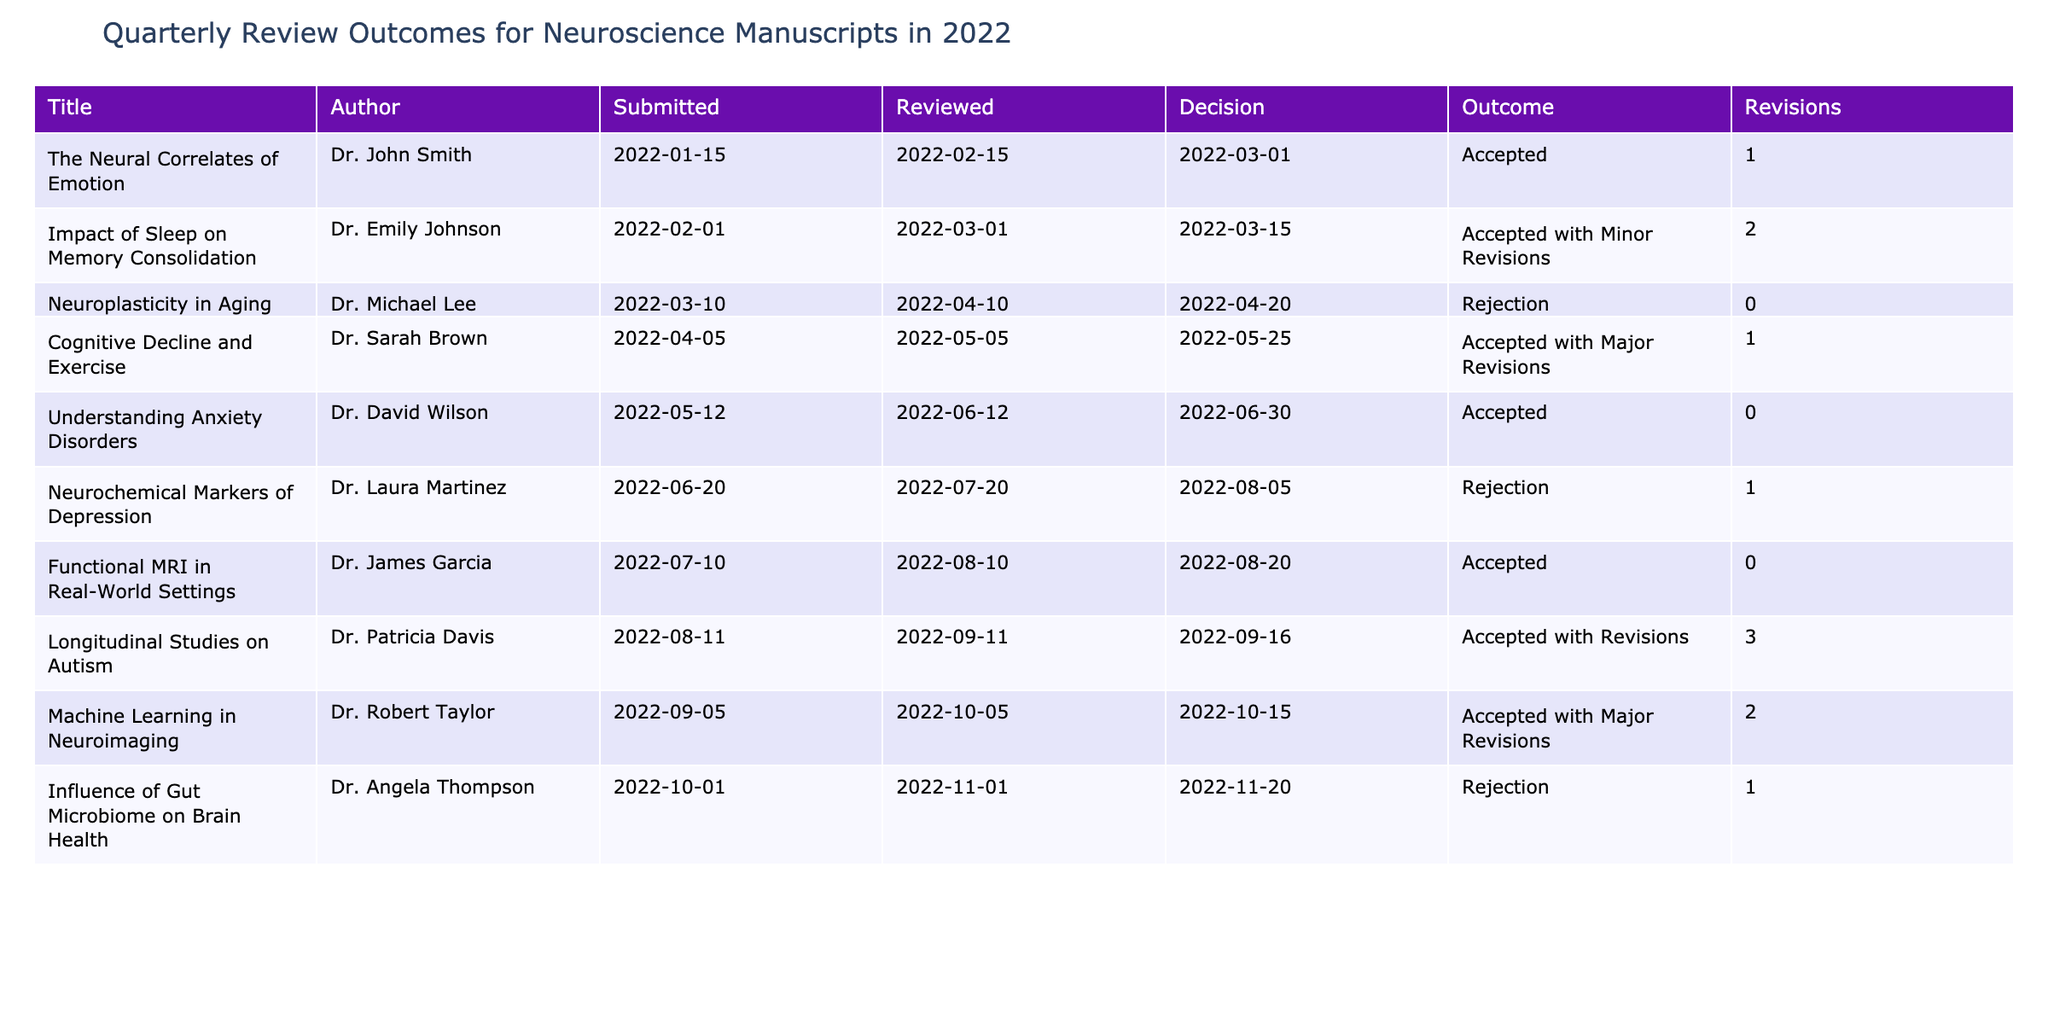What is the outcome of "The Neural Correlates of Emotion"? The table shows that the outcome for "The Neural Correlates of Emotion" by Dr. John Smith is listed as "Accepted."
Answer: Accepted How many manuscripts were accepted with minor revisions? Examining the table, "Impact of Sleep on Memory Consolidation" and "Longitudinal Studies on Autism" are the only manuscripts that fall under the category of "Accepted with Minor Revisions," which totals to two papers.
Answer: 2 Did Dr. Michael Lee's manuscript receive any revisions before rejection? According to the table, "Neuroplasticity in Aging" was rejected and has a revision count of 0, indicating that no revisions were made before the rejection decision.
Answer: No What is the ratio of accepted manuscripts to rejected manuscripts? From the table, there are five accepted manuscripts ("The Neural Correlates of Emotion," "Impact of Sleep on Memory Consolidation," "Understanding Anxiety Disorders," "Functional MRI in Real-World Settings," and "Machine Learning in Neuroimaging") and four rejected manuscripts ("Neuroplasticity in Aging," "Neurochemical Markers of Depression," and "Influence of Gut Microbiome on Brain Health"). Thus, the ratio is 5:4.
Answer: 5:4 How many revisions were made in total for all manuscripts? By summing the "Revise_Count" from the table: 1 (for "The Neural Correlates of Emotion") + 2 (for "Impact of Sleep on Memory Consolidation") + 1 (for "Cognitive Decline and Exercise") + 0 (for "Understanding Anxiety Disorders") + 1 (for "Neurochemical Markers of Depression") + 3 (for "Longitudinal Studies on Autism") + 2 (for "Machine Learning in Neuroimaging") = 10. Therefore, the total number of revisions is 10.
Answer: 10 Which author had the most revisions, and how many were there? Looking through the table, Dr. Patricia Davis had the most revisions with a total of 3 for the manuscript "Longitudinal Studies on Autism." This is higher than any other author listed in the table.
Answer: Dr. Patricia Davis, 3 revisions 